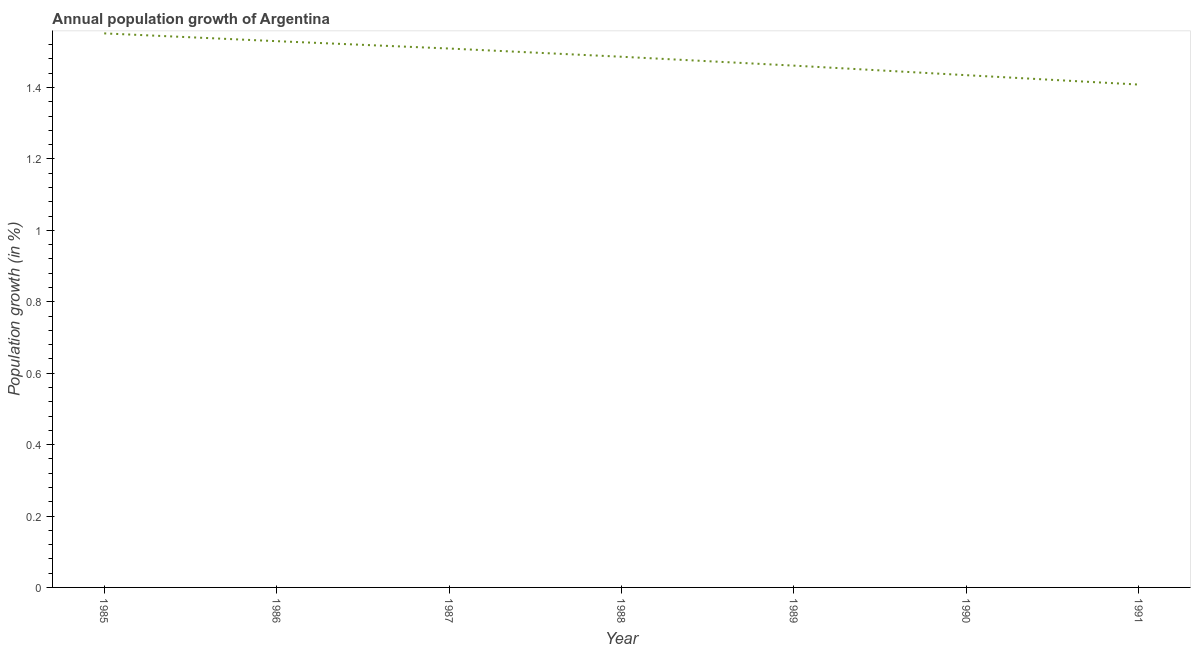What is the population growth in 1988?
Ensure brevity in your answer.  1.49. Across all years, what is the maximum population growth?
Your answer should be compact. 1.55. Across all years, what is the minimum population growth?
Keep it short and to the point. 1.41. In which year was the population growth maximum?
Offer a terse response. 1985. What is the sum of the population growth?
Your response must be concise. 10.38. What is the difference between the population growth in 1987 and 1991?
Provide a short and direct response. 0.1. What is the average population growth per year?
Your answer should be compact. 1.48. What is the median population growth?
Ensure brevity in your answer.  1.49. Do a majority of the years between 1987 and 1989 (inclusive) have population growth greater than 0.36 %?
Provide a succinct answer. Yes. What is the ratio of the population growth in 1988 to that in 1991?
Offer a terse response. 1.06. What is the difference between the highest and the second highest population growth?
Ensure brevity in your answer.  0.02. What is the difference between the highest and the lowest population growth?
Give a very brief answer. 0.14. In how many years, is the population growth greater than the average population growth taken over all years?
Your answer should be compact. 4. How many years are there in the graph?
Keep it short and to the point. 7. Are the values on the major ticks of Y-axis written in scientific E-notation?
Give a very brief answer. No. Does the graph contain grids?
Offer a very short reply. No. What is the title of the graph?
Offer a very short reply. Annual population growth of Argentina. What is the label or title of the Y-axis?
Provide a succinct answer. Population growth (in %). What is the Population growth (in %) in 1985?
Ensure brevity in your answer.  1.55. What is the Population growth (in %) of 1986?
Offer a terse response. 1.53. What is the Population growth (in %) in 1987?
Provide a succinct answer. 1.51. What is the Population growth (in %) in 1988?
Give a very brief answer. 1.49. What is the Population growth (in %) in 1989?
Your answer should be very brief. 1.46. What is the Population growth (in %) in 1990?
Provide a succinct answer. 1.43. What is the Population growth (in %) of 1991?
Your answer should be very brief. 1.41. What is the difference between the Population growth (in %) in 1985 and 1986?
Provide a short and direct response. 0.02. What is the difference between the Population growth (in %) in 1985 and 1987?
Ensure brevity in your answer.  0.04. What is the difference between the Population growth (in %) in 1985 and 1988?
Offer a very short reply. 0.07. What is the difference between the Population growth (in %) in 1985 and 1989?
Provide a short and direct response. 0.09. What is the difference between the Population growth (in %) in 1985 and 1990?
Give a very brief answer. 0.12. What is the difference between the Population growth (in %) in 1985 and 1991?
Keep it short and to the point. 0.14. What is the difference between the Population growth (in %) in 1986 and 1987?
Keep it short and to the point. 0.02. What is the difference between the Population growth (in %) in 1986 and 1988?
Provide a succinct answer. 0.04. What is the difference between the Population growth (in %) in 1986 and 1989?
Provide a succinct answer. 0.07. What is the difference between the Population growth (in %) in 1986 and 1990?
Offer a terse response. 0.1. What is the difference between the Population growth (in %) in 1986 and 1991?
Provide a succinct answer. 0.12. What is the difference between the Population growth (in %) in 1987 and 1988?
Your answer should be very brief. 0.02. What is the difference between the Population growth (in %) in 1987 and 1989?
Offer a very short reply. 0.05. What is the difference between the Population growth (in %) in 1987 and 1990?
Keep it short and to the point. 0.07. What is the difference between the Population growth (in %) in 1987 and 1991?
Keep it short and to the point. 0.1. What is the difference between the Population growth (in %) in 1988 and 1989?
Your answer should be compact. 0.02. What is the difference between the Population growth (in %) in 1988 and 1990?
Your response must be concise. 0.05. What is the difference between the Population growth (in %) in 1988 and 1991?
Provide a succinct answer. 0.08. What is the difference between the Population growth (in %) in 1989 and 1990?
Give a very brief answer. 0.03. What is the difference between the Population growth (in %) in 1989 and 1991?
Your answer should be very brief. 0.05. What is the difference between the Population growth (in %) in 1990 and 1991?
Provide a short and direct response. 0.03. What is the ratio of the Population growth (in %) in 1985 to that in 1987?
Your response must be concise. 1.03. What is the ratio of the Population growth (in %) in 1985 to that in 1988?
Make the answer very short. 1.04. What is the ratio of the Population growth (in %) in 1985 to that in 1989?
Give a very brief answer. 1.06. What is the ratio of the Population growth (in %) in 1985 to that in 1990?
Your response must be concise. 1.08. What is the ratio of the Population growth (in %) in 1985 to that in 1991?
Make the answer very short. 1.1. What is the ratio of the Population growth (in %) in 1986 to that in 1987?
Give a very brief answer. 1.01. What is the ratio of the Population growth (in %) in 1986 to that in 1988?
Keep it short and to the point. 1.03. What is the ratio of the Population growth (in %) in 1986 to that in 1989?
Your answer should be compact. 1.05. What is the ratio of the Population growth (in %) in 1986 to that in 1990?
Give a very brief answer. 1.07. What is the ratio of the Population growth (in %) in 1986 to that in 1991?
Make the answer very short. 1.09. What is the ratio of the Population growth (in %) in 1987 to that in 1989?
Offer a terse response. 1.03. What is the ratio of the Population growth (in %) in 1987 to that in 1990?
Provide a short and direct response. 1.05. What is the ratio of the Population growth (in %) in 1987 to that in 1991?
Your answer should be very brief. 1.07. What is the ratio of the Population growth (in %) in 1988 to that in 1989?
Make the answer very short. 1.02. What is the ratio of the Population growth (in %) in 1988 to that in 1990?
Give a very brief answer. 1.04. What is the ratio of the Population growth (in %) in 1988 to that in 1991?
Offer a terse response. 1.05. What is the ratio of the Population growth (in %) in 1989 to that in 1990?
Your response must be concise. 1.02. What is the ratio of the Population growth (in %) in 1989 to that in 1991?
Offer a very short reply. 1.04. 